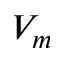<formula> <loc_0><loc_0><loc_500><loc_500>V _ { m }</formula> 